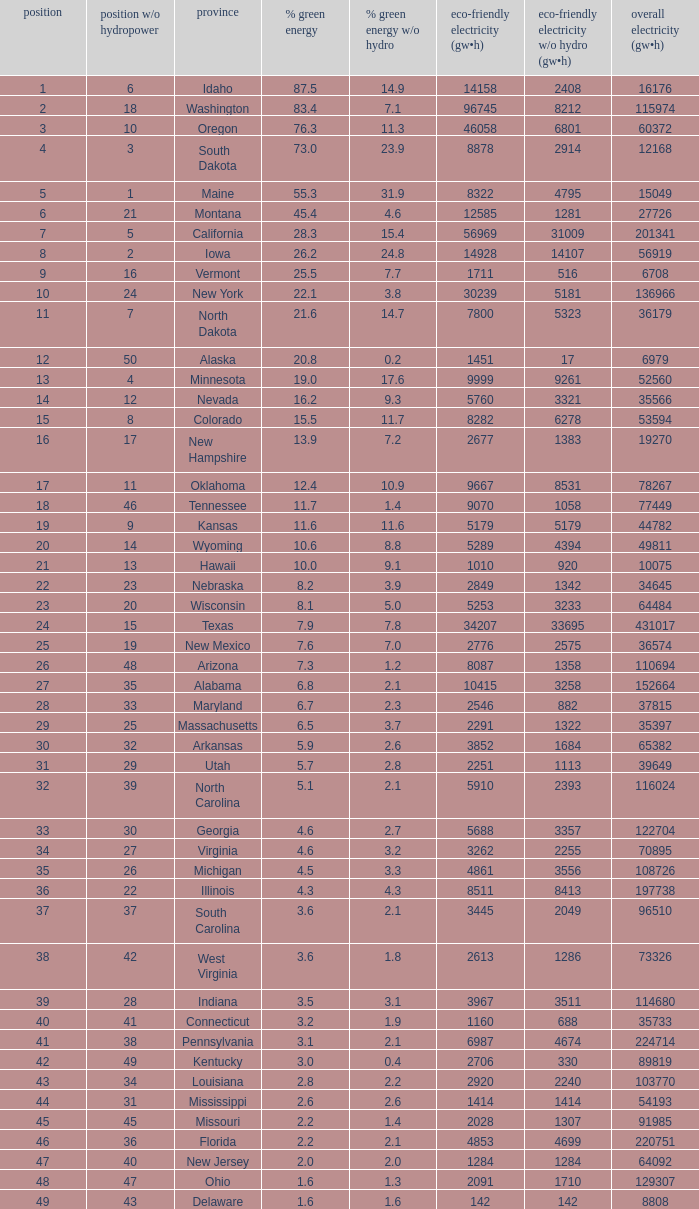What is the maximum renewable energy (gw×h) for the state of Delaware? 142.0. 